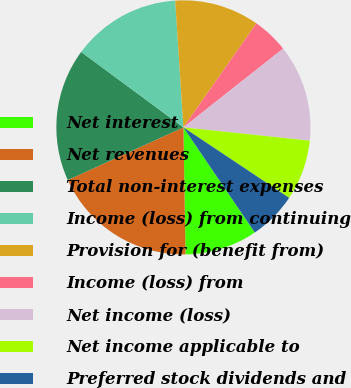Convert chart. <chart><loc_0><loc_0><loc_500><loc_500><pie_chart><fcel>Net interest<fcel>Net revenues<fcel>Total non-interest expenses<fcel>Income (loss) from continuing<fcel>Provision for (benefit from)<fcel>Income (loss) from<fcel>Net income (loss)<fcel>Net income applicable to<fcel>Preferred stock dividends and<nl><fcel>9.23%<fcel>18.46%<fcel>16.92%<fcel>13.85%<fcel>10.77%<fcel>4.62%<fcel>12.31%<fcel>7.69%<fcel>6.15%<nl></chart> 